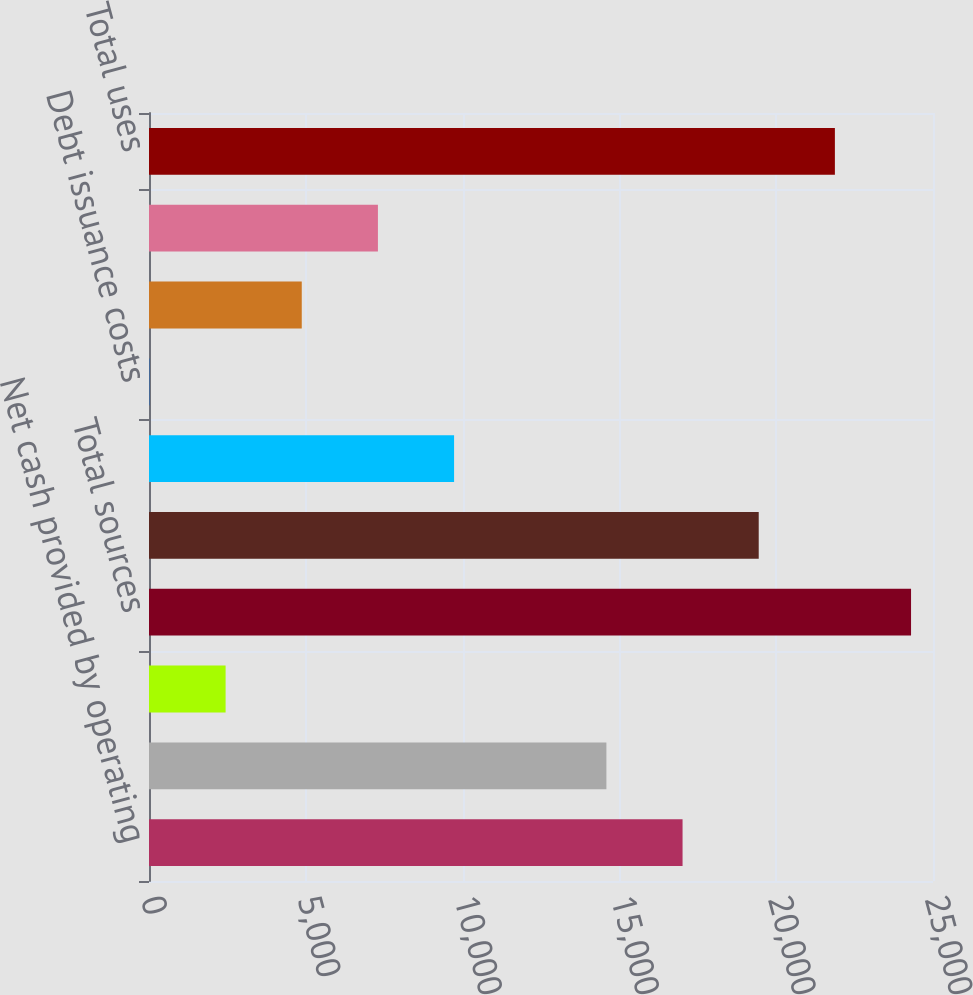Convert chart to OTSL. <chart><loc_0><loc_0><loc_500><loc_500><bar_chart><fcel>Net cash provided by operating<fcel>Long-term debt issued<fcel>Stock options exercised<fcel>Total sources<fcel>Net cash used in investing<fcel>Long-term debt repaid<fcel>Debt issuance costs<fcel>Dividends on preferred stock<fcel>Dividends on common stock<fcel>Total uses<nl><fcel>17014.2<fcel>14585.6<fcel>2442.6<fcel>24300<fcel>19442.8<fcel>9728.4<fcel>14<fcel>4871.2<fcel>7299.8<fcel>21871.4<nl></chart> 